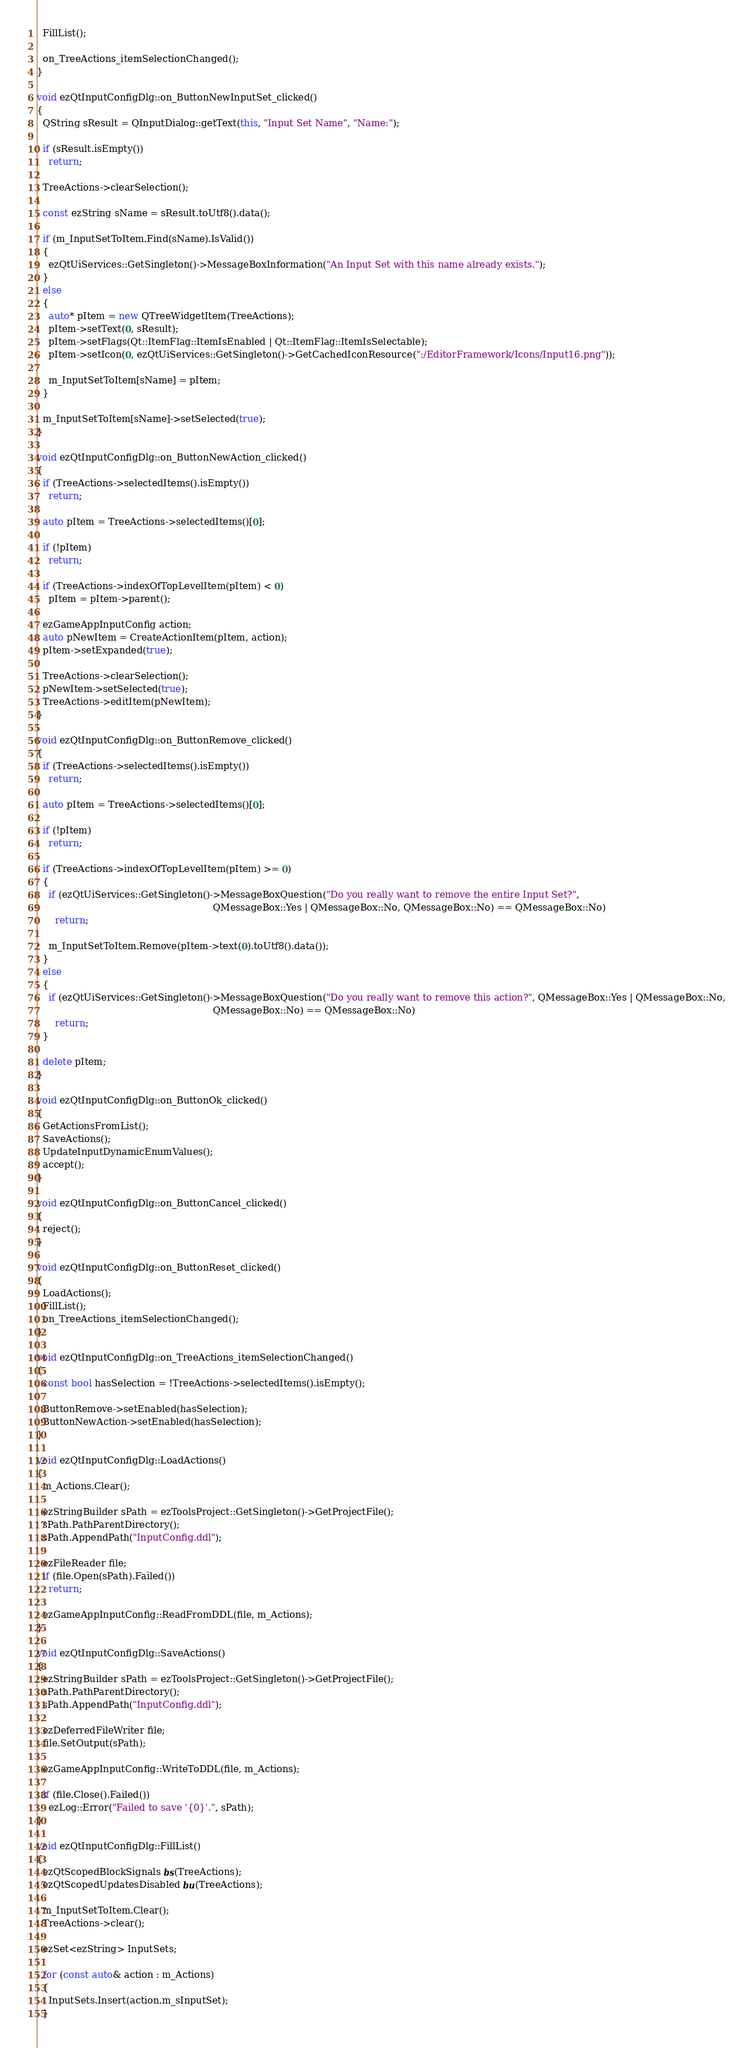Convert code to text. <code><loc_0><loc_0><loc_500><loc_500><_C++_>
  FillList();

  on_TreeActions_itemSelectionChanged();
}

void ezQtInputConfigDlg::on_ButtonNewInputSet_clicked()
{
  QString sResult = QInputDialog::getText(this, "Input Set Name", "Name:");

  if (sResult.isEmpty())
    return;

  TreeActions->clearSelection();

  const ezString sName = sResult.toUtf8().data();

  if (m_InputSetToItem.Find(sName).IsValid())
  {
    ezQtUiServices::GetSingleton()->MessageBoxInformation("An Input Set with this name already exists.");
  }
  else
  {
    auto* pItem = new QTreeWidgetItem(TreeActions);
    pItem->setText(0, sResult);
    pItem->setFlags(Qt::ItemFlag::ItemIsEnabled | Qt::ItemFlag::ItemIsSelectable);
    pItem->setIcon(0, ezQtUiServices::GetSingleton()->GetCachedIconResource(":/EditorFramework/Icons/Input16.png"));

    m_InputSetToItem[sName] = pItem;
  }

  m_InputSetToItem[sName]->setSelected(true);
}

void ezQtInputConfigDlg::on_ButtonNewAction_clicked()
{
  if (TreeActions->selectedItems().isEmpty())
    return;

  auto pItem = TreeActions->selectedItems()[0];

  if (!pItem)
    return;

  if (TreeActions->indexOfTopLevelItem(pItem) < 0)
    pItem = pItem->parent();

  ezGameAppInputConfig action;
  auto pNewItem = CreateActionItem(pItem, action);
  pItem->setExpanded(true);

  TreeActions->clearSelection();
  pNewItem->setSelected(true);
  TreeActions->editItem(pNewItem);
}

void ezQtInputConfigDlg::on_ButtonRemove_clicked()
{
  if (TreeActions->selectedItems().isEmpty())
    return;

  auto pItem = TreeActions->selectedItems()[0];

  if (!pItem)
    return;

  if (TreeActions->indexOfTopLevelItem(pItem) >= 0)
  {
    if (ezQtUiServices::GetSingleton()->MessageBoxQuestion("Do you really want to remove the entire Input Set?",
                                                           QMessageBox::Yes | QMessageBox::No, QMessageBox::No) == QMessageBox::No)
      return;

    m_InputSetToItem.Remove(pItem->text(0).toUtf8().data());
  }
  else
  {
    if (ezQtUiServices::GetSingleton()->MessageBoxQuestion("Do you really want to remove this action?", QMessageBox::Yes | QMessageBox::No,
                                                           QMessageBox::No) == QMessageBox::No)
      return;
  }

  delete pItem;
}

void ezQtInputConfigDlg::on_ButtonOk_clicked()
{
  GetActionsFromList();
  SaveActions();
  UpdateInputDynamicEnumValues();
  accept();
}

void ezQtInputConfigDlg::on_ButtonCancel_clicked()
{
  reject();
}

void ezQtInputConfigDlg::on_ButtonReset_clicked()
{
  LoadActions();
  FillList();
  on_TreeActions_itemSelectionChanged();
}

void ezQtInputConfigDlg::on_TreeActions_itemSelectionChanged()
{
  const bool hasSelection = !TreeActions->selectedItems().isEmpty();

  ButtonRemove->setEnabled(hasSelection);
  ButtonNewAction->setEnabled(hasSelection);
}

void ezQtInputConfigDlg::LoadActions()
{
  m_Actions.Clear();

  ezStringBuilder sPath = ezToolsProject::GetSingleton()->GetProjectFile();
  sPath.PathParentDirectory();
  sPath.AppendPath("InputConfig.ddl");

  ezFileReader file;
  if (file.Open(sPath).Failed())
    return;

  ezGameAppInputConfig::ReadFromDDL(file, m_Actions);
}

void ezQtInputConfigDlg::SaveActions()
{
  ezStringBuilder sPath = ezToolsProject::GetSingleton()->GetProjectFile();
  sPath.PathParentDirectory();
  sPath.AppendPath("InputConfig.ddl");

  ezDeferredFileWriter file;
  file.SetOutput(sPath);

  ezGameAppInputConfig::WriteToDDL(file, m_Actions);

  if (file.Close().Failed())
    ezLog::Error("Failed to save '{0}'.", sPath);
}

void ezQtInputConfigDlg::FillList()
{
  ezQtScopedBlockSignals bs(TreeActions);
  ezQtScopedUpdatesDisabled bu(TreeActions);

  m_InputSetToItem.Clear();
  TreeActions->clear();

  ezSet<ezString> InputSets;

  for (const auto& action : m_Actions)
  {
    InputSets.Insert(action.m_sInputSet);
  }
</code> 